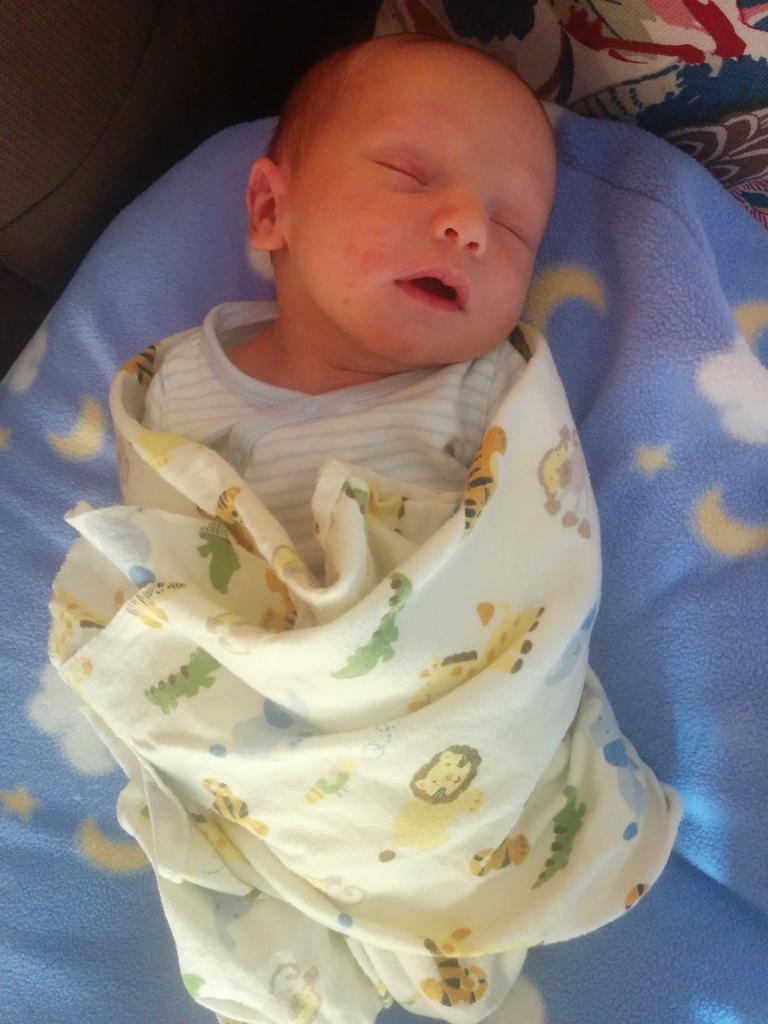In one or two sentences, can you explain what this image depicts? In this picture there is a baby lying on the bed and there is an object on the bed. 